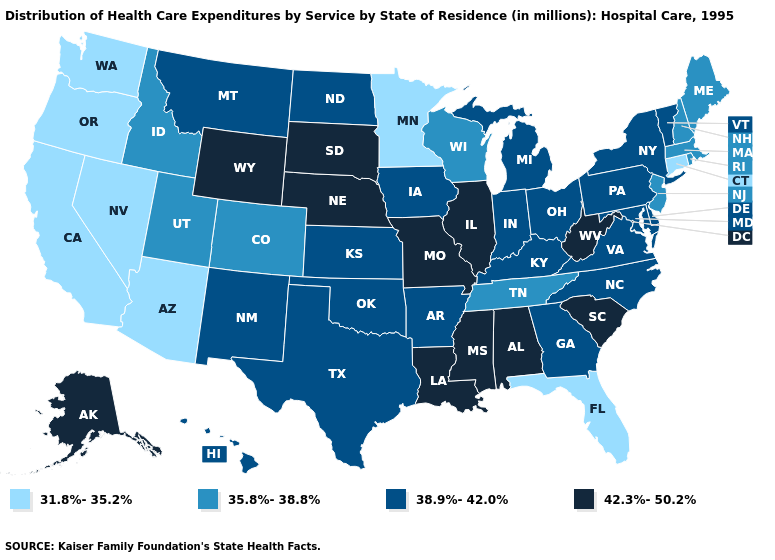Does the map have missing data?
Be succinct. No. Name the states that have a value in the range 38.9%-42.0%?
Concise answer only. Arkansas, Delaware, Georgia, Hawaii, Indiana, Iowa, Kansas, Kentucky, Maryland, Michigan, Montana, New Mexico, New York, North Carolina, North Dakota, Ohio, Oklahoma, Pennsylvania, Texas, Vermont, Virginia. Does the map have missing data?
Give a very brief answer. No. What is the lowest value in the Northeast?
Concise answer only. 31.8%-35.2%. Name the states that have a value in the range 42.3%-50.2%?
Give a very brief answer. Alabama, Alaska, Illinois, Louisiana, Mississippi, Missouri, Nebraska, South Carolina, South Dakota, West Virginia, Wyoming. Which states have the highest value in the USA?
Write a very short answer. Alabama, Alaska, Illinois, Louisiana, Mississippi, Missouri, Nebraska, South Carolina, South Dakota, West Virginia, Wyoming. Does Arizona have a higher value than Massachusetts?
Quick response, please. No. What is the value of Idaho?
Be succinct. 35.8%-38.8%. What is the value of Delaware?
Quick response, please. 38.9%-42.0%. Does Wyoming have the lowest value in the USA?
Write a very short answer. No. Among the states that border Ohio , which have the lowest value?
Give a very brief answer. Indiana, Kentucky, Michigan, Pennsylvania. What is the highest value in the MidWest ?
Quick response, please. 42.3%-50.2%. Name the states that have a value in the range 31.8%-35.2%?
Concise answer only. Arizona, California, Connecticut, Florida, Minnesota, Nevada, Oregon, Washington. Name the states that have a value in the range 42.3%-50.2%?
Keep it brief. Alabama, Alaska, Illinois, Louisiana, Mississippi, Missouri, Nebraska, South Carolina, South Dakota, West Virginia, Wyoming. 